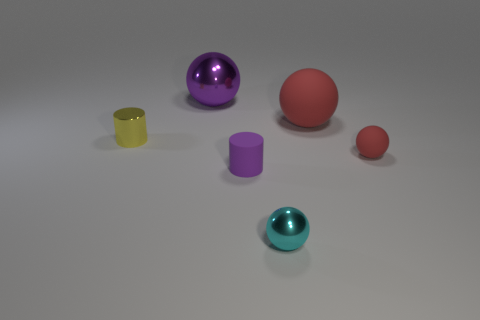Are there any tiny cylinders that are right of the sphere left of the rubber thing that is on the left side of the large red rubber thing?
Your response must be concise. Yes. Is the number of small objects greater than the number of things?
Offer a terse response. No. What color is the small ball behind the tiny cyan object?
Give a very brief answer. Red. Is the number of cylinders that are behind the tiny metallic cylinder greater than the number of purple matte objects?
Offer a very short reply. No. Are the purple ball and the tiny red object made of the same material?
Ensure brevity in your answer.  No. How many other objects are the same shape as the small purple rubber object?
Provide a succinct answer. 1. The rubber ball that is in front of the big thing on the right side of the metal sphere in front of the big metallic thing is what color?
Keep it short and to the point. Red. There is a tiny matte object that is right of the tiny purple cylinder; is its shape the same as the large purple metallic thing?
Ensure brevity in your answer.  Yes. How many tiny purple matte cylinders are there?
Your answer should be compact. 1. What number of yellow metal cylinders are the same size as the yellow metal object?
Give a very brief answer. 0. 